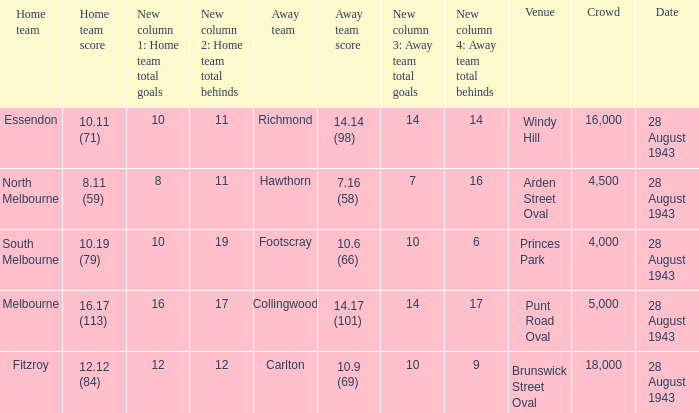11 (59)? 28 August 1943. 